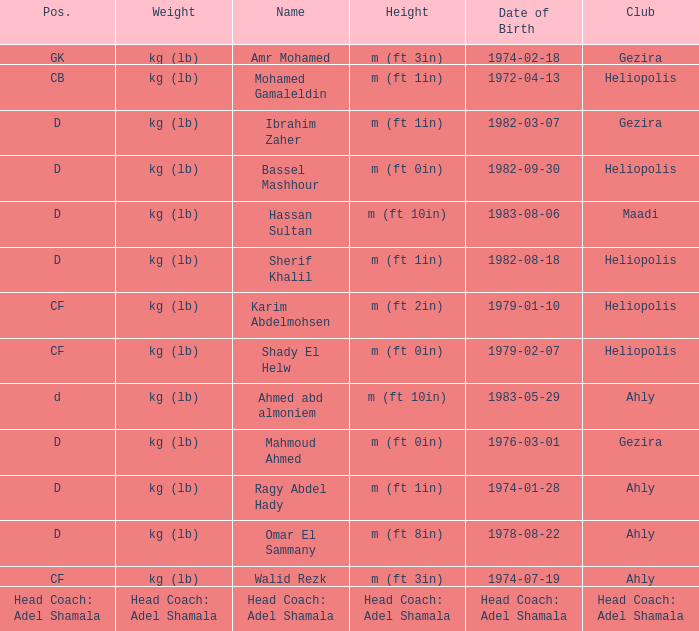What is Weight, when Club is "Ahly", and when Name is "Ragy Abdel Hady"? Kg (lb). 